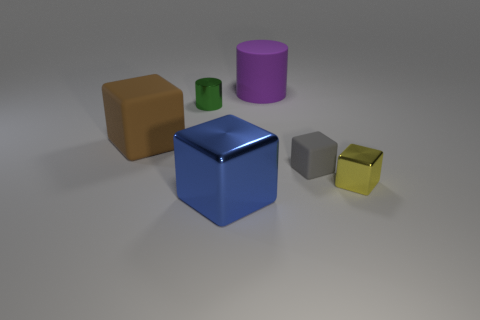Add 2 yellow blocks. How many objects exist? 8 Subtract all purple cubes. Subtract all yellow spheres. How many cubes are left? 4 Subtract all cubes. How many objects are left? 2 Subtract 0 green balls. How many objects are left? 6 Subtract all green matte cylinders. Subtract all large blue metal blocks. How many objects are left? 5 Add 3 big rubber blocks. How many big rubber blocks are left? 4 Add 6 small blue metal things. How many small blue metal things exist? 6 